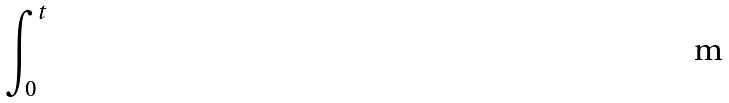Convert formula to latex. <formula><loc_0><loc_0><loc_500><loc_500>\int _ { 0 } ^ { t }</formula> 